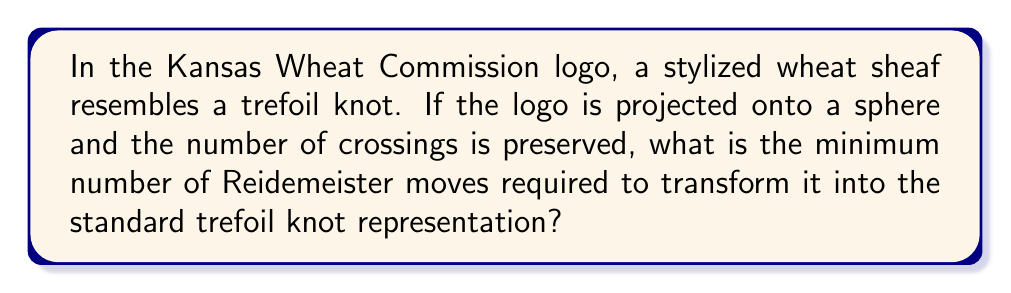What is the answer to this math problem? Let's approach this step-by-step:

1. The Kansas Wheat Commission logo features a stylized wheat sheaf that resembles a trefoil knot. This is significant as it connects our state's primary crop to a fundamental concept in knot theory.

2. A trefoil knot is the simplest non-trivial knot, with a crossing number of 3. The wheat sheaf logo, when viewed as a knot, also has 3 crossings.

3. When we project the logo onto a sphere, we preserve the number of crossings. This is important because it means we're dealing with the same knot type.

4. The standard representation of a trefoil knot is typically drawn as:

   [asy]
   import geometry;

   path p = (0,0)..controls(1,1)and(2,1)..(3,0)..controls(2,-1)and(1,-1)..(0,0);
   path q = (0,0)..controls(1,1)and(2,1)..(3,0);
   path r = (0,0)..controls(1,-1)and(2,-1)..(3,0);

   draw(p);
   draw(q);
   draw(r);
   [/asy]

5. Reidemeister moves are operations that can be performed on a knot diagram without changing the knot type. There are three types of Reidemeister moves:
   - Type I: Twist or untwist a strand
   - Type II: Move one strand completely over or under another
   - Type III: Move a strand over or under a crossing

6. To transform the wheat sheaf logo into the standard trefoil representation, we need to perform a series of Reidemeister moves.

7. The minimum number of moves required is 2:
   - One Type II move to straighten out one of the "leaves" of the wheat sheaf
   - One Type III move to adjust the final crossing

8. It's worth noting that this minimum number is the same regardless of the specific stylization of the wheat sheaf, as long as it maintains the trefoil structure with three crossings.
Answer: 2 Reidemeister moves 